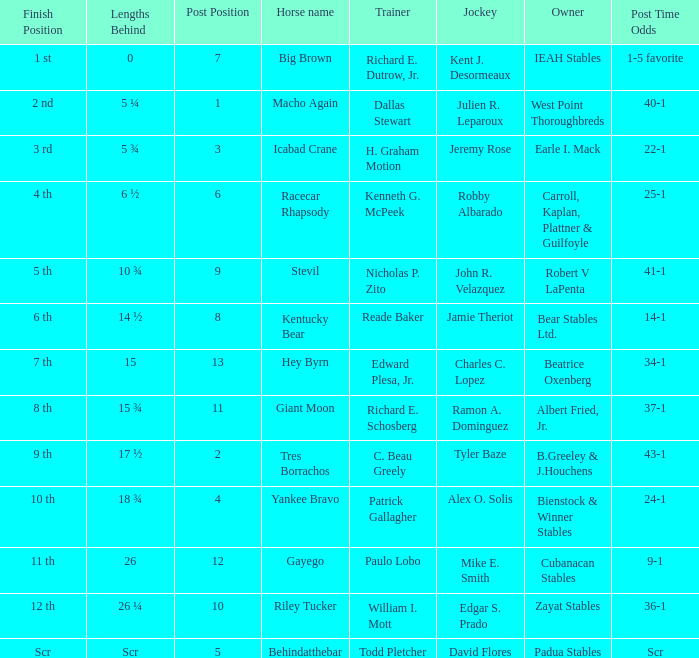Parse the table in full. {'header': ['Finish Position', 'Lengths Behind', 'Post Position', 'Horse name', 'Trainer', 'Jockey', 'Owner', 'Post Time Odds'], 'rows': [['1 st', '0', '7', 'Big Brown', 'Richard E. Dutrow, Jr.', 'Kent J. Desormeaux', 'IEAH Stables', '1-5 favorite'], ['2 nd', '5 ¼', '1', 'Macho Again', 'Dallas Stewart', 'Julien R. Leparoux', 'West Point Thoroughbreds', '40-1'], ['3 rd', '5 ¾', '3', 'Icabad Crane', 'H. Graham Motion', 'Jeremy Rose', 'Earle I. Mack', '22-1'], ['4 th', '6 ½', '6', 'Racecar Rhapsody', 'Kenneth G. McPeek', 'Robby Albarado', 'Carroll, Kaplan, Plattner & Guilfoyle', '25-1'], ['5 th', '10 ¾', '9', 'Stevil', 'Nicholas P. Zito', 'John R. Velazquez', 'Robert V LaPenta', '41-1'], ['6 th', '14 ½', '8', 'Kentucky Bear', 'Reade Baker', 'Jamie Theriot', 'Bear Stables Ltd.', '14-1'], ['7 th', '15', '13', 'Hey Byrn', 'Edward Plesa, Jr.', 'Charles C. Lopez', 'Beatrice Oxenberg', '34-1'], ['8 th', '15 ¾', '11', 'Giant Moon', 'Richard E. Schosberg', 'Ramon A. Dominguez', 'Albert Fried, Jr.', '37-1'], ['9 th', '17 ½', '2', 'Tres Borrachos', 'C. Beau Greely', 'Tyler Baze', 'B.Greeley & J.Houchens', '43-1'], ['10 th', '18 ¾', '4', 'Yankee Bravo', 'Patrick Gallagher', 'Alex O. Solis', 'Bienstock & Winner Stables', '24-1'], ['11 th', '26', '12', 'Gayego', 'Paulo Lobo', 'Mike E. Smith', 'Cubanacan Stables', '9-1'], ['12 th', '26 ¼', '10', 'Riley Tucker', 'William I. Mott', 'Edgar S. Prado', 'Zayat Stables', '36-1'], ['Scr', 'Scr', '5', 'Behindatthebar', 'Todd Pletcher', 'David Flores', 'Padua Stables', 'Scr']]} What is the lengths behind of Jeremy Rose? 5 ¾. 